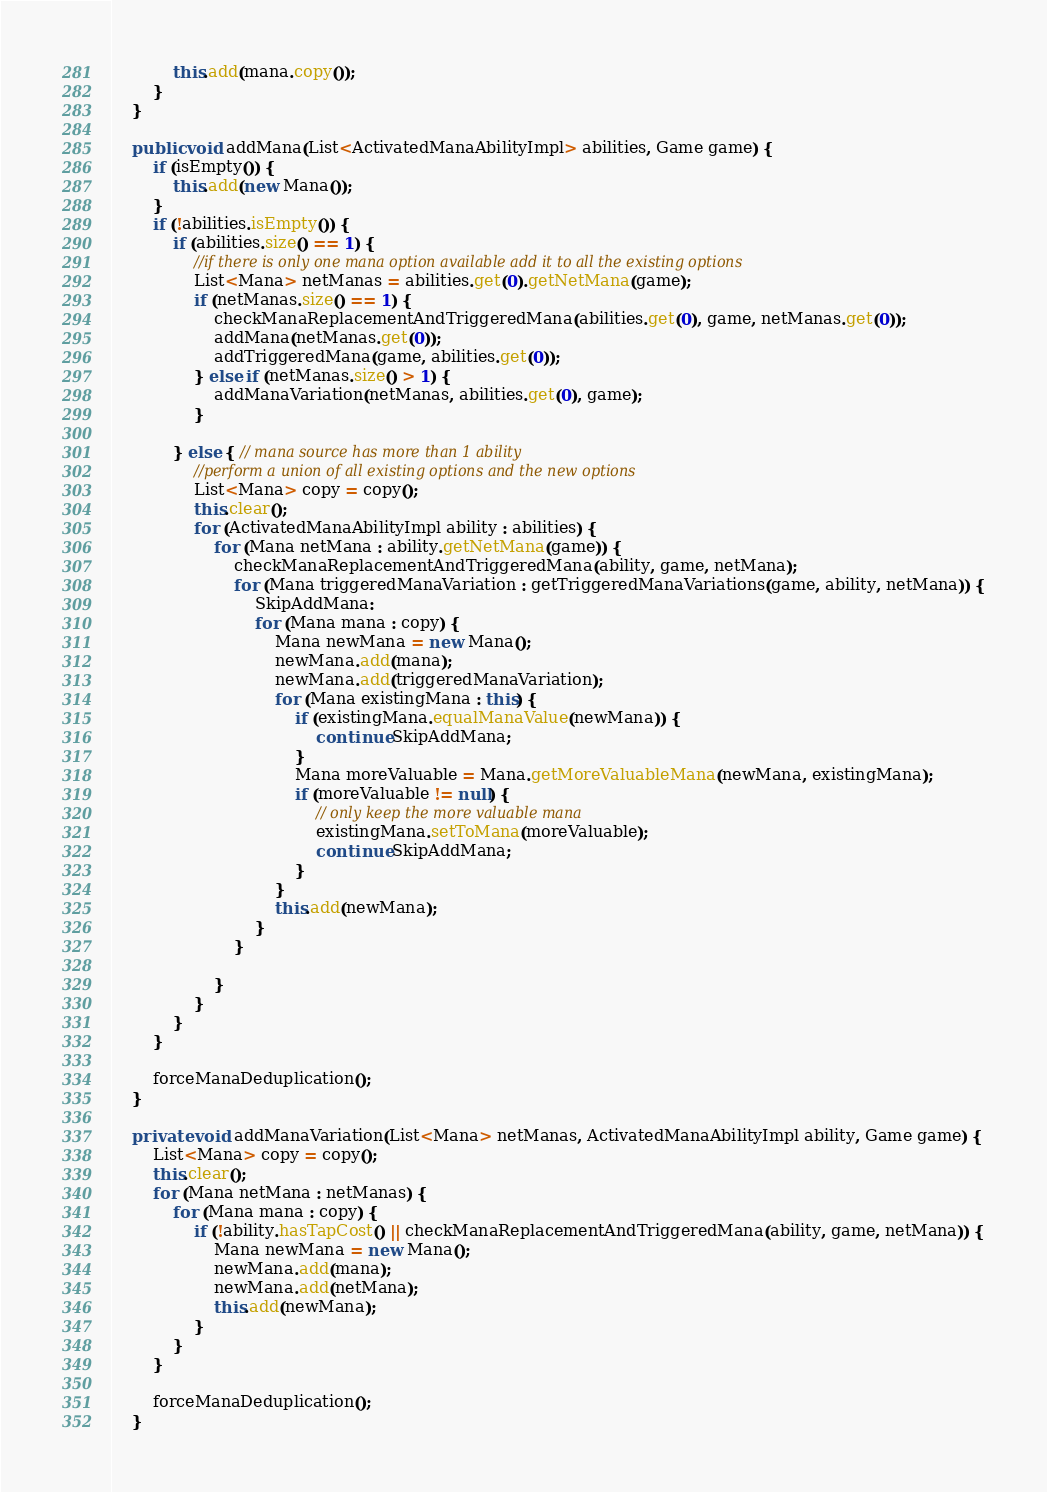<code> <loc_0><loc_0><loc_500><loc_500><_Java_>            this.add(mana.copy());
        }
    }

    public void addMana(List<ActivatedManaAbilityImpl> abilities, Game game) {
        if (isEmpty()) {
            this.add(new Mana());
        }
        if (!abilities.isEmpty()) {
            if (abilities.size() == 1) {
                //if there is only one mana option available add it to all the existing options
                List<Mana> netManas = abilities.get(0).getNetMana(game);
                if (netManas.size() == 1) {
                    checkManaReplacementAndTriggeredMana(abilities.get(0), game, netManas.get(0));
                    addMana(netManas.get(0));
                    addTriggeredMana(game, abilities.get(0));
                } else if (netManas.size() > 1) {
                    addManaVariation(netManas, abilities.get(0), game);
                }

            } else { // mana source has more than 1 ability
                //perform a union of all existing options and the new options
                List<Mana> copy = copy();
                this.clear();
                for (ActivatedManaAbilityImpl ability : abilities) {
                    for (Mana netMana : ability.getNetMana(game)) {
                        checkManaReplacementAndTriggeredMana(ability, game, netMana);
                        for (Mana triggeredManaVariation : getTriggeredManaVariations(game, ability, netMana)) {
                            SkipAddMana:
                            for (Mana mana : copy) {
                                Mana newMana = new Mana();
                                newMana.add(mana);
                                newMana.add(triggeredManaVariation);
                                for (Mana existingMana : this) {
                                    if (existingMana.equalManaValue(newMana)) {
                                        continue SkipAddMana;
                                    }
                                    Mana moreValuable = Mana.getMoreValuableMana(newMana, existingMana);
                                    if (moreValuable != null) {
                                        // only keep the more valuable mana
                                        existingMana.setToMana(moreValuable);
                                        continue SkipAddMana;
                                    }
                                }
                                this.add(newMana);
                            }
                        }

                    }
                }
            }
        }

        forceManaDeduplication();
    }

    private void addManaVariation(List<Mana> netManas, ActivatedManaAbilityImpl ability, Game game) {
        List<Mana> copy = copy();
        this.clear();
        for (Mana netMana : netManas) {
            for (Mana mana : copy) {
                if (!ability.hasTapCost() || checkManaReplacementAndTriggeredMana(ability, game, netMana)) {
                    Mana newMana = new Mana();
                    newMana.add(mana);
                    newMana.add(netMana);
                    this.add(newMana);
                }
            }
        }

        forceManaDeduplication();
    }
</code> 